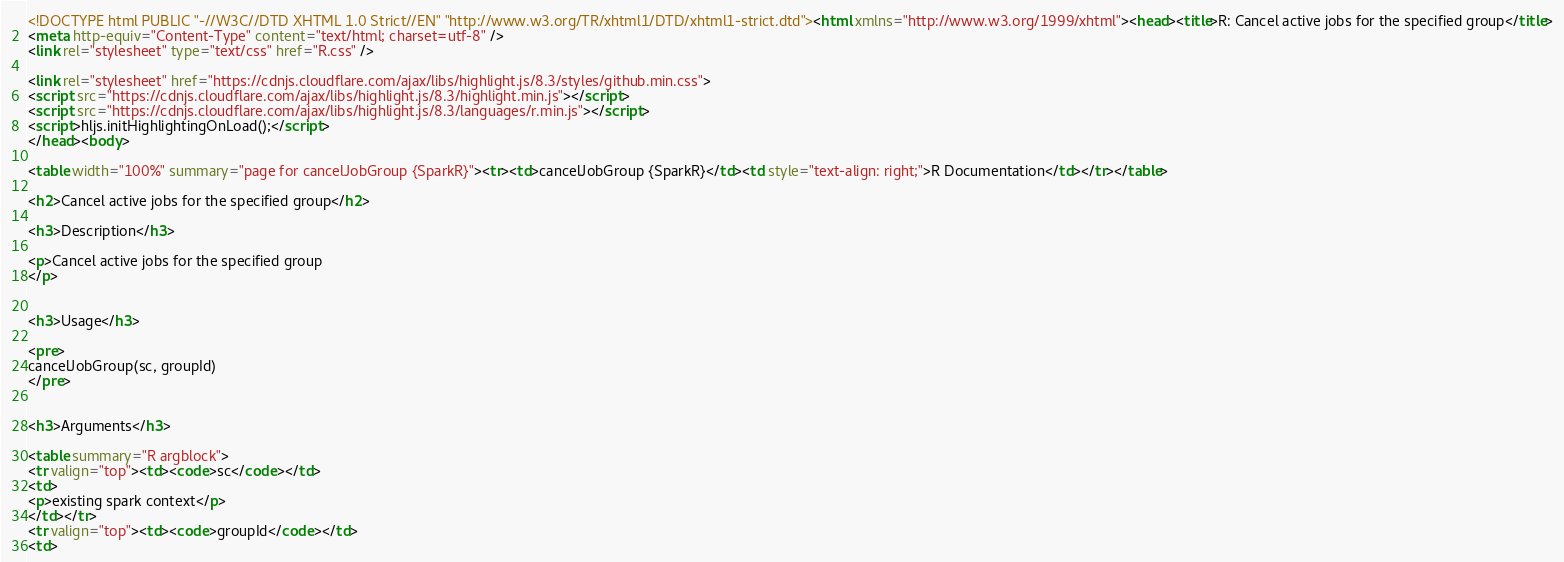<code> <loc_0><loc_0><loc_500><loc_500><_HTML_><!DOCTYPE html PUBLIC "-//W3C//DTD XHTML 1.0 Strict//EN" "http://www.w3.org/TR/xhtml1/DTD/xhtml1-strict.dtd"><html xmlns="http://www.w3.org/1999/xhtml"><head><title>R: Cancel active jobs for the specified group</title>
<meta http-equiv="Content-Type" content="text/html; charset=utf-8" />
<link rel="stylesheet" type="text/css" href="R.css" />

<link rel="stylesheet" href="https://cdnjs.cloudflare.com/ajax/libs/highlight.js/8.3/styles/github.min.css">
<script src="https://cdnjs.cloudflare.com/ajax/libs/highlight.js/8.3/highlight.min.js"></script>
<script src="https://cdnjs.cloudflare.com/ajax/libs/highlight.js/8.3/languages/r.min.js"></script>
<script>hljs.initHighlightingOnLoad();</script>
</head><body>

<table width="100%" summary="page for cancelJobGroup {SparkR}"><tr><td>cancelJobGroup {SparkR}</td><td style="text-align: right;">R Documentation</td></tr></table>

<h2>Cancel active jobs for the specified group</h2>

<h3>Description</h3>

<p>Cancel active jobs for the specified group
</p>


<h3>Usage</h3>

<pre>
cancelJobGroup(sc, groupId)
</pre>


<h3>Arguments</h3>

<table summary="R argblock">
<tr valign="top"><td><code>sc</code></td>
<td>
<p>existing spark context</p>
</td></tr>
<tr valign="top"><td><code>groupId</code></td>
<td></code> 